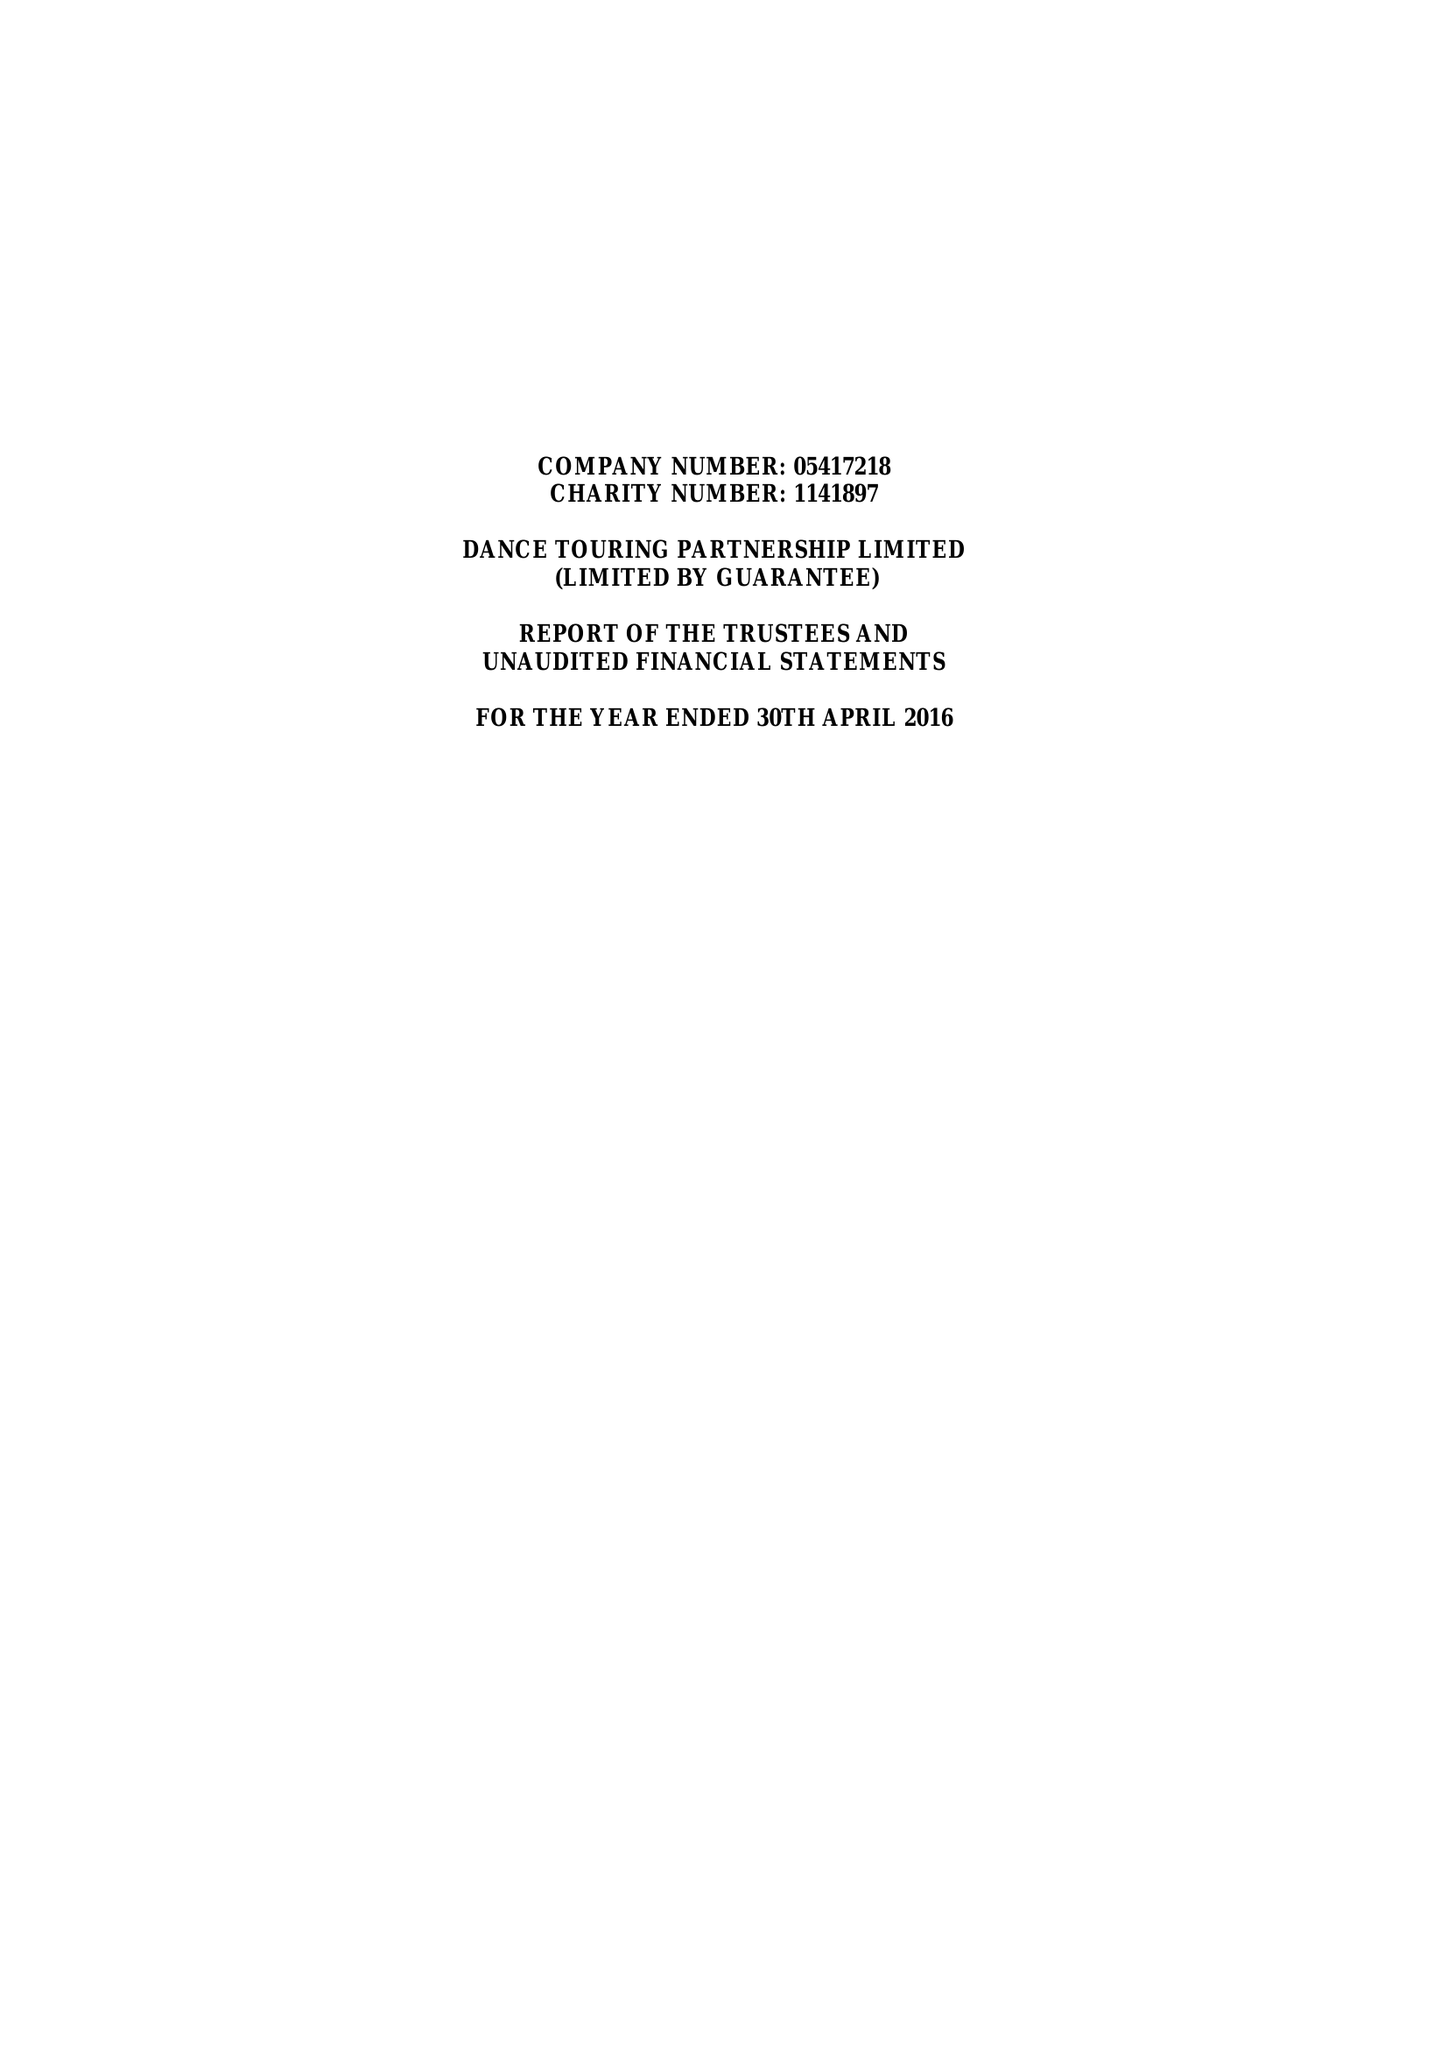What is the value for the charity_name?
Answer the question using a single word or phrase. Dance Touring Partnership Ltd. 